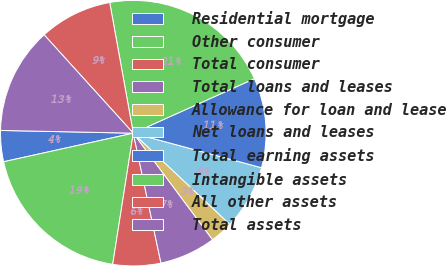Convert chart. <chart><loc_0><loc_0><loc_500><loc_500><pie_chart><fcel>Residential mortgage<fcel>Other consumer<fcel>Total consumer<fcel>Total loans and leases<fcel>Allowance for loan and lease<fcel>Net loans and leases<fcel>Total earning assets<fcel>Intangible assets<fcel>All other assets<fcel>Total assets<nl><fcel>3.78%<fcel>19.07%<fcel>5.82%<fcel>6.84%<fcel>2.77%<fcel>7.86%<fcel>10.92%<fcel>21.11%<fcel>8.88%<fcel>12.95%<nl></chart> 